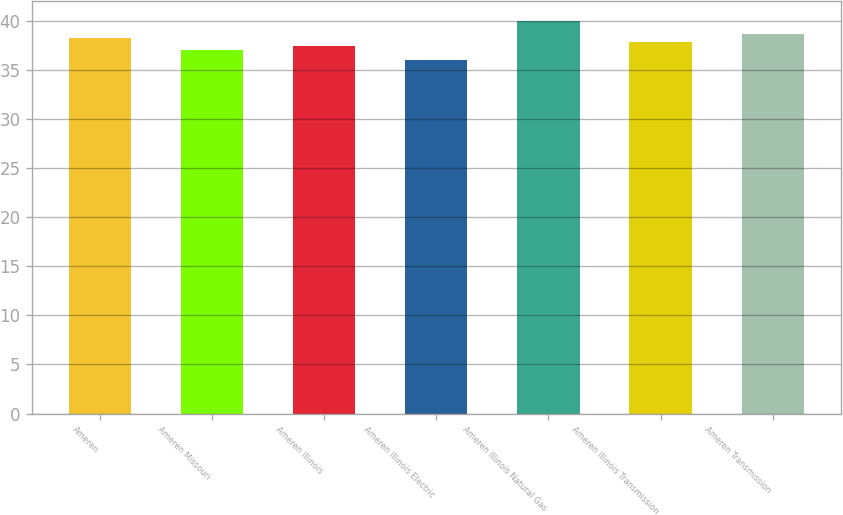<chart> <loc_0><loc_0><loc_500><loc_500><bar_chart><fcel>Ameren<fcel>Ameren Missouri<fcel>Ameren Illinois<fcel>Ameren Illinois Electric<fcel>Ameren Illinois Natural Gas<fcel>Ameren Illinois Transmission<fcel>Ameren Transmission<nl><fcel>38.2<fcel>37<fcel>37.4<fcel>36<fcel>40<fcel>37.8<fcel>38.6<nl></chart> 